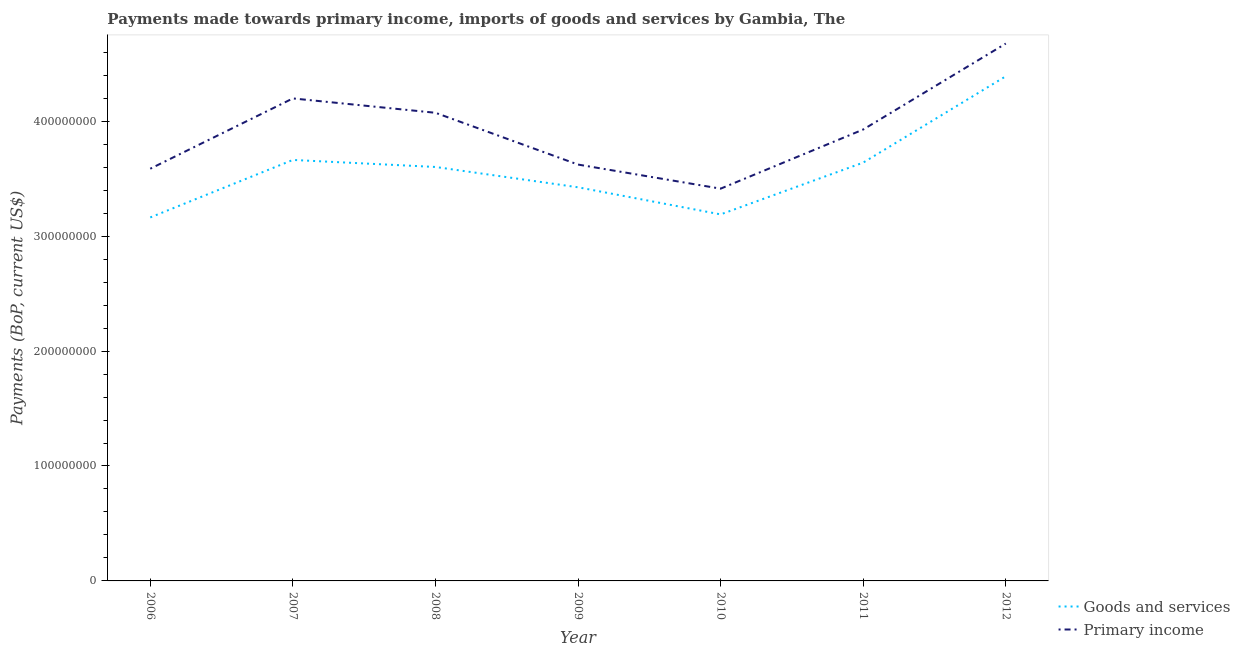What is the payments made towards primary income in 2012?
Your answer should be compact. 4.68e+08. Across all years, what is the maximum payments made towards primary income?
Make the answer very short. 4.68e+08. Across all years, what is the minimum payments made towards goods and services?
Your answer should be compact. 3.16e+08. In which year was the payments made towards goods and services maximum?
Keep it short and to the point. 2012. In which year was the payments made towards primary income minimum?
Provide a succinct answer. 2010. What is the total payments made towards goods and services in the graph?
Provide a short and direct response. 2.51e+09. What is the difference between the payments made towards primary income in 2006 and that in 2007?
Your response must be concise. -6.12e+07. What is the difference between the payments made towards primary income in 2006 and the payments made towards goods and services in 2010?
Ensure brevity in your answer.  3.97e+07. What is the average payments made towards goods and services per year?
Your answer should be very brief. 3.58e+08. In the year 2011, what is the difference between the payments made towards primary income and payments made towards goods and services?
Provide a succinct answer. 2.88e+07. What is the ratio of the payments made towards primary income in 2006 to that in 2012?
Offer a very short reply. 0.77. Is the difference between the payments made towards goods and services in 2007 and 2008 greater than the difference between the payments made towards primary income in 2007 and 2008?
Your response must be concise. No. What is the difference between the highest and the second highest payments made towards primary income?
Ensure brevity in your answer.  4.77e+07. What is the difference between the highest and the lowest payments made towards primary income?
Your response must be concise. 1.26e+08. In how many years, is the payments made towards primary income greater than the average payments made towards primary income taken over all years?
Provide a succinct answer. 3. Does the payments made towards primary income monotonically increase over the years?
Keep it short and to the point. No. How many lines are there?
Offer a very short reply. 2. Are the values on the major ticks of Y-axis written in scientific E-notation?
Provide a succinct answer. No. Does the graph contain grids?
Provide a short and direct response. No. Where does the legend appear in the graph?
Offer a terse response. Bottom right. How many legend labels are there?
Your answer should be very brief. 2. How are the legend labels stacked?
Make the answer very short. Vertical. What is the title of the graph?
Ensure brevity in your answer.  Payments made towards primary income, imports of goods and services by Gambia, The. What is the label or title of the X-axis?
Your response must be concise. Year. What is the label or title of the Y-axis?
Offer a terse response. Payments (BoP, current US$). What is the Payments (BoP, current US$) of Goods and services in 2006?
Your response must be concise. 3.16e+08. What is the Payments (BoP, current US$) in Primary income in 2006?
Your response must be concise. 3.59e+08. What is the Payments (BoP, current US$) in Goods and services in 2007?
Your answer should be very brief. 3.66e+08. What is the Payments (BoP, current US$) of Primary income in 2007?
Keep it short and to the point. 4.20e+08. What is the Payments (BoP, current US$) of Goods and services in 2008?
Your answer should be very brief. 3.60e+08. What is the Payments (BoP, current US$) in Primary income in 2008?
Keep it short and to the point. 4.07e+08. What is the Payments (BoP, current US$) in Goods and services in 2009?
Provide a succinct answer. 3.43e+08. What is the Payments (BoP, current US$) of Primary income in 2009?
Make the answer very short. 3.62e+08. What is the Payments (BoP, current US$) of Goods and services in 2010?
Provide a succinct answer. 3.19e+08. What is the Payments (BoP, current US$) of Primary income in 2010?
Provide a short and direct response. 3.41e+08. What is the Payments (BoP, current US$) in Goods and services in 2011?
Your answer should be very brief. 3.64e+08. What is the Payments (BoP, current US$) in Primary income in 2011?
Offer a very short reply. 3.93e+08. What is the Payments (BoP, current US$) of Goods and services in 2012?
Give a very brief answer. 4.39e+08. What is the Payments (BoP, current US$) of Primary income in 2012?
Keep it short and to the point. 4.68e+08. Across all years, what is the maximum Payments (BoP, current US$) of Goods and services?
Make the answer very short. 4.39e+08. Across all years, what is the maximum Payments (BoP, current US$) in Primary income?
Your answer should be compact. 4.68e+08. Across all years, what is the minimum Payments (BoP, current US$) in Goods and services?
Give a very brief answer. 3.16e+08. Across all years, what is the minimum Payments (BoP, current US$) in Primary income?
Offer a terse response. 3.41e+08. What is the total Payments (BoP, current US$) of Goods and services in the graph?
Your answer should be compact. 2.51e+09. What is the total Payments (BoP, current US$) in Primary income in the graph?
Your answer should be very brief. 2.75e+09. What is the difference between the Payments (BoP, current US$) of Goods and services in 2006 and that in 2007?
Provide a succinct answer. -5.00e+07. What is the difference between the Payments (BoP, current US$) of Primary income in 2006 and that in 2007?
Your answer should be very brief. -6.12e+07. What is the difference between the Payments (BoP, current US$) of Goods and services in 2006 and that in 2008?
Offer a very short reply. -4.39e+07. What is the difference between the Payments (BoP, current US$) in Primary income in 2006 and that in 2008?
Offer a very short reply. -4.87e+07. What is the difference between the Payments (BoP, current US$) of Goods and services in 2006 and that in 2009?
Give a very brief answer. -2.62e+07. What is the difference between the Payments (BoP, current US$) of Primary income in 2006 and that in 2009?
Provide a short and direct response. -3.62e+06. What is the difference between the Payments (BoP, current US$) in Goods and services in 2006 and that in 2010?
Give a very brief answer. -2.65e+06. What is the difference between the Payments (BoP, current US$) of Primary income in 2006 and that in 2010?
Give a very brief answer. 1.73e+07. What is the difference between the Payments (BoP, current US$) of Goods and services in 2006 and that in 2011?
Keep it short and to the point. -4.77e+07. What is the difference between the Payments (BoP, current US$) of Primary income in 2006 and that in 2011?
Make the answer very short. -3.41e+07. What is the difference between the Payments (BoP, current US$) in Goods and services in 2006 and that in 2012?
Provide a short and direct response. -1.23e+08. What is the difference between the Payments (BoP, current US$) in Primary income in 2006 and that in 2012?
Offer a very short reply. -1.09e+08. What is the difference between the Payments (BoP, current US$) in Goods and services in 2007 and that in 2008?
Your answer should be compact. 6.12e+06. What is the difference between the Payments (BoP, current US$) in Primary income in 2007 and that in 2008?
Your answer should be compact. 1.25e+07. What is the difference between the Payments (BoP, current US$) in Goods and services in 2007 and that in 2009?
Offer a very short reply. 2.38e+07. What is the difference between the Payments (BoP, current US$) of Primary income in 2007 and that in 2009?
Your response must be concise. 5.75e+07. What is the difference between the Payments (BoP, current US$) in Goods and services in 2007 and that in 2010?
Keep it short and to the point. 4.74e+07. What is the difference between the Payments (BoP, current US$) in Primary income in 2007 and that in 2010?
Your answer should be compact. 7.85e+07. What is the difference between the Payments (BoP, current US$) in Goods and services in 2007 and that in 2011?
Your answer should be very brief. 2.31e+06. What is the difference between the Payments (BoP, current US$) in Primary income in 2007 and that in 2011?
Provide a succinct answer. 2.70e+07. What is the difference between the Payments (BoP, current US$) in Goods and services in 2007 and that in 2012?
Offer a terse response. -7.28e+07. What is the difference between the Payments (BoP, current US$) of Primary income in 2007 and that in 2012?
Your answer should be compact. -4.77e+07. What is the difference between the Payments (BoP, current US$) of Goods and services in 2008 and that in 2009?
Offer a terse response. 1.77e+07. What is the difference between the Payments (BoP, current US$) of Primary income in 2008 and that in 2009?
Offer a very short reply. 4.51e+07. What is the difference between the Payments (BoP, current US$) of Goods and services in 2008 and that in 2010?
Your answer should be compact. 4.13e+07. What is the difference between the Payments (BoP, current US$) of Primary income in 2008 and that in 2010?
Your response must be concise. 6.60e+07. What is the difference between the Payments (BoP, current US$) in Goods and services in 2008 and that in 2011?
Provide a short and direct response. -3.81e+06. What is the difference between the Payments (BoP, current US$) in Primary income in 2008 and that in 2011?
Provide a short and direct response. 1.46e+07. What is the difference between the Payments (BoP, current US$) of Goods and services in 2008 and that in 2012?
Offer a very short reply. -7.89e+07. What is the difference between the Payments (BoP, current US$) in Primary income in 2008 and that in 2012?
Give a very brief answer. -6.02e+07. What is the difference between the Payments (BoP, current US$) of Goods and services in 2009 and that in 2010?
Make the answer very short. 2.36e+07. What is the difference between the Payments (BoP, current US$) in Primary income in 2009 and that in 2010?
Keep it short and to the point. 2.10e+07. What is the difference between the Payments (BoP, current US$) in Goods and services in 2009 and that in 2011?
Your answer should be compact. -2.15e+07. What is the difference between the Payments (BoP, current US$) in Primary income in 2009 and that in 2011?
Provide a succinct answer. -3.05e+07. What is the difference between the Payments (BoP, current US$) of Goods and services in 2009 and that in 2012?
Provide a short and direct response. -9.66e+07. What is the difference between the Payments (BoP, current US$) in Primary income in 2009 and that in 2012?
Provide a succinct answer. -1.05e+08. What is the difference between the Payments (BoP, current US$) in Goods and services in 2010 and that in 2011?
Make the answer very short. -4.51e+07. What is the difference between the Payments (BoP, current US$) in Primary income in 2010 and that in 2011?
Give a very brief answer. -5.15e+07. What is the difference between the Payments (BoP, current US$) in Goods and services in 2010 and that in 2012?
Give a very brief answer. -1.20e+08. What is the difference between the Payments (BoP, current US$) of Primary income in 2010 and that in 2012?
Provide a succinct answer. -1.26e+08. What is the difference between the Payments (BoP, current US$) of Goods and services in 2011 and that in 2012?
Ensure brevity in your answer.  -7.51e+07. What is the difference between the Payments (BoP, current US$) of Primary income in 2011 and that in 2012?
Provide a short and direct response. -7.48e+07. What is the difference between the Payments (BoP, current US$) in Goods and services in 2006 and the Payments (BoP, current US$) in Primary income in 2007?
Give a very brief answer. -1.04e+08. What is the difference between the Payments (BoP, current US$) of Goods and services in 2006 and the Payments (BoP, current US$) of Primary income in 2008?
Provide a succinct answer. -9.11e+07. What is the difference between the Payments (BoP, current US$) of Goods and services in 2006 and the Payments (BoP, current US$) of Primary income in 2009?
Offer a terse response. -4.60e+07. What is the difference between the Payments (BoP, current US$) in Goods and services in 2006 and the Payments (BoP, current US$) in Primary income in 2010?
Ensure brevity in your answer.  -2.50e+07. What is the difference between the Payments (BoP, current US$) in Goods and services in 2006 and the Payments (BoP, current US$) in Primary income in 2011?
Offer a terse response. -7.65e+07. What is the difference between the Payments (BoP, current US$) in Goods and services in 2006 and the Payments (BoP, current US$) in Primary income in 2012?
Give a very brief answer. -1.51e+08. What is the difference between the Payments (BoP, current US$) in Goods and services in 2007 and the Payments (BoP, current US$) in Primary income in 2008?
Your response must be concise. -4.10e+07. What is the difference between the Payments (BoP, current US$) of Goods and services in 2007 and the Payments (BoP, current US$) of Primary income in 2009?
Offer a terse response. 4.02e+06. What is the difference between the Payments (BoP, current US$) of Goods and services in 2007 and the Payments (BoP, current US$) of Primary income in 2010?
Ensure brevity in your answer.  2.50e+07. What is the difference between the Payments (BoP, current US$) in Goods and services in 2007 and the Payments (BoP, current US$) in Primary income in 2011?
Provide a succinct answer. -2.65e+07. What is the difference between the Payments (BoP, current US$) in Goods and services in 2007 and the Payments (BoP, current US$) in Primary income in 2012?
Provide a succinct answer. -1.01e+08. What is the difference between the Payments (BoP, current US$) in Goods and services in 2008 and the Payments (BoP, current US$) in Primary income in 2009?
Offer a very short reply. -2.10e+06. What is the difference between the Payments (BoP, current US$) in Goods and services in 2008 and the Payments (BoP, current US$) in Primary income in 2010?
Make the answer very short. 1.89e+07. What is the difference between the Payments (BoP, current US$) in Goods and services in 2008 and the Payments (BoP, current US$) in Primary income in 2011?
Offer a very short reply. -3.26e+07. What is the difference between the Payments (BoP, current US$) in Goods and services in 2008 and the Payments (BoP, current US$) in Primary income in 2012?
Provide a short and direct response. -1.07e+08. What is the difference between the Payments (BoP, current US$) of Goods and services in 2009 and the Payments (BoP, current US$) of Primary income in 2010?
Offer a very short reply. 1.19e+06. What is the difference between the Payments (BoP, current US$) of Goods and services in 2009 and the Payments (BoP, current US$) of Primary income in 2011?
Offer a very short reply. -5.03e+07. What is the difference between the Payments (BoP, current US$) of Goods and services in 2009 and the Payments (BoP, current US$) of Primary income in 2012?
Provide a succinct answer. -1.25e+08. What is the difference between the Payments (BoP, current US$) in Goods and services in 2010 and the Payments (BoP, current US$) in Primary income in 2011?
Ensure brevity in your answer.  -7.39e+07. What is the difference between the Payments (BoP, current US$) in Goods and services in 2010 and the Payments (BoP, current US$) in Primary income in 2012?
Make the answer very short. -1.49e+08. What is the difference between the Payments (BoP, current US$) in Goods and services in 2011 and the Payments (BoP, current US$) in Primary income in 2012?
Give a very brief answer. -1.04e+08. What is the average Payments (BoP, current US$) in Goods and services per year?
Keep it short and to the point. 3.58e+08. What is the average Payments (BoP, current US$) of Primary income per year?
Keep it short and to the point. 3.93e+08. In the year 2006, what is the difference between the Payments (BoP, current US$) in Goods and services and Payments (BoP, current US$) in Primary income?
Your answer should be very brief. -4.24e+07. In the year 2007, what is the difference between the Payments (BoP, current US$) in Goods and services and Payments (BoP, current US$) in Primary income?
Your answer should be compact. -5.35e+07. In the year 2008, what is the difference between the Payments (BoP, current US$) in Goods and services and Payments (BoP, current US$) in Primary income?
Provide a short and direct response. -4.72e+07. In the year 2009, what is the difference between the Payments (BoP, current US$) in Goods and services and Payments (BoP, current US$) in Primary income?
Offer a very short reply. -1.98e+07. In the year 2010, what is the difference between the Payments (BoP, current US$) of Goods and services and Payments (BoP, current US$) of Primary income?
Provide a succinct answer. -2.24e+07. In the year 2011, what is the difference between the Payments (BoP, current US$) in Goods and services and Payments (BoP, current US$) in Primary income?
Ensure brevity in your answer.  -2.88e+07. In the year 2012, what is the difference between the Payments (BoP, current US$) of Goods and services and Payments (BoP, current US$) of Primary income?
Make the answer very short. -2.85e+07. What is the ratio of the Payments (BoP, current US$) of Goods and services in 2006 to that in 2007?
Your response must be concise. 0.86. What is the ratio of the Payments (BoP, current US$) in Primary income in 2006 to that in 2007?
Ensure brevity in your answer.  0.85. What is the ratio of the Payments (BoP, current US$) in Goods and services in 2006 to that in 2008?
Provide a short and direct response. 0.88. What is the ratio of the Payments (BoP, current US$) of Primary income in 2006 to that in 2008?
Make the answer very short. 0.88. What is the ratio of the Payments (BoP, current US$) of Goods and services in 2006 to that in 2009?
Make the answer very short. 0.92. What is the ratio of the Payments (BoP, current US$) in Goods and services in 2006 to that in 2010?
Offer a terse response. 0.99. What is the ratio of the Payments (BoP, current US$) of Primary income in 2006 to that in 2010?
Make the answer very short. 1.05. What is the ratio of the Payments (BoP, current US$) in Goods and services in 2006 to that in 2011?
Keep it short and to the point. 0.87. What is the ratio of the Payments (BoP, current US$) in Primary income in 2006 to that in 2011?
Offer a terse response. 0.91. What is the ratio of the Payments (BoP, current US$) of Goods and services in 2006 to that in 2012?
Offer a very short reply. 0.72. What is the ratio of the Payments (BoP, current US$) in Primary income in 2006 to that in 2012?
Offer a terse response. 0.77. What is the ratio of the Payments (BoP, current US$) in Goods and services in 2007 to that in 2008?
Offer a very short reply. 1.02. What is the ratio of the Payments (BoP, current US$) of Primary income in 2007 to that in 2008?
Offer a very short reply. 1.03. What is the ratio of the Payments (BoP, current US$) in Goods and services in 2007 to that in 2009?
Your answer should be very brief. 1.07. What is the ratio of the Payments (BoP, current US$) in Primary income in 2007 to that in 2009?
Your answer should be compact. 1.16. What is the ratio of the Payments (BoP, current US$) of Goods and services in 2007 to that in 2010?
Offer a very short reply. 1.15. What is the ratio of the Payments (BoP, current US$) in Primary income in 2007 to that in 2010?
Offer a terse response. 1.23. What is the ratio of the Payments (BoP, current US$) in Primary income in 2007 to that in 2011?
Provide a succinct answer. 1.07. What is the ratio of the Payments (BoP, current US$) in Goods and services in 2007 to that in 2012?
Your response must be concise. 0.83. What is the ratio of the Payments (BoP, current US$) of Primary income in 2007 to that in 2012?
Keep it short and to the point. 0.9. What is the ratio of the Payments (BoP, current US$) in Goods and services in 2008 to that in 2009?
Your answer should be compact. 1.05. What is the ratio of the Payments (BoP, current US$) in Primary income in 2008 to that in 2009?
Make the answer very short. 1.12. What is the ratio of the Payments (BoP, current US$) of Goods and services in 2008 to that in 2010?
Offer a terse response. 1.13. What is the ratio of the Payments (BoP, current US$) of Primary income in 2008 to that in 2010?
Provide a short and direct response. 1.19. What is the ratio of the Payments (BoP, current US$) of Goods and services in 2008 to that in 2011?
Offer a very short reply. 0.99. What is the ratio of the Payments (BoP, current US$) of Primary income in 2008 to that in 2011?
Your answer should be very brief. 1.04. What is the ratio of the Payments (BoP, current US$) of Goods and services in 2008 to that in 2012?
Offer a very short reply. 0.82. What is the ratio of the Payments (BoP, current US$) of Primary income in 2008 to that in 2012?
Give a very brief answer. 0.87. What is the ratio of the Payments (BoP, current US$) of Goods and services in 2009 to that in 2010?
Provide a short and direct response. 1.07. What is the ratio of the Payments (BoP, current US$) of Primary income in 2009 to that in 2010?
Ensure brevity in your answer.  1.06. What is the ratio of the Payments (BoP, current US$) of Goods and services in 2009 to that in 2011?
Provide a short and direct response. 0.94. What is the ratio of the Payments (BoP, current US$) of Primary income in 2009 to that in 2011?
Offer a very short reply. 0.92. What is the ratio of the Payments (BoP, current US$) of Goods and services in 2009 to that in 2012?
Provide a short and direct response. 0.78. What is the ratio of the Payments (BoP, current US$) in Primary income in 2009 to that in 2012?
Ensure brevity in your answer.  0.77. What is the ratio of the Payments (BoP, current US$) of Goods and services in 2010 to that in 2011?
Keep it short and to the point. 0.88. What is the ratio of the Payments (BoP, current US$) of Primary income in 2010 to that in 2011?
Make the answer very short. 0.87. What is the ratio of the Payments (BoP, current US$) of Goods and services in 2010 to that in 2012?
Make the answer very short. 0.73. What is the ratio of the Payments (BoP, current US$) of Primary income in 2010 to that in 2012?
Your answer should be very brief. 0.73. What is the ratio of the Payments (BoP, current US$) in Goods and services in 2011 to that in 2012?
Give a very brief answer. 0.83. What is the ratio of the Payments (BoP, current US$) of Primary income in 2011 to that in 2012?
Ensure brevity in your answer.  0.84. What is the difference between the highest and the second highest Payments (BoP, current US$) of Goods and services?
Your response must be concise. 7.28e+07. What is the difference between the highest and the second highest Payments (BoP, current US$) of Primary income?
Provide a short and direct response. 4.77e+07. What is the difference between the highest and the lowest Payments (BoP, current US$) in Goods and services?
Provide a succinct answer. 1.23e+08. What is the difference between the highest and the lowest Payments (BoP, current US$) in Primary income?
Keep it short and to the point. 1.26e+08. 